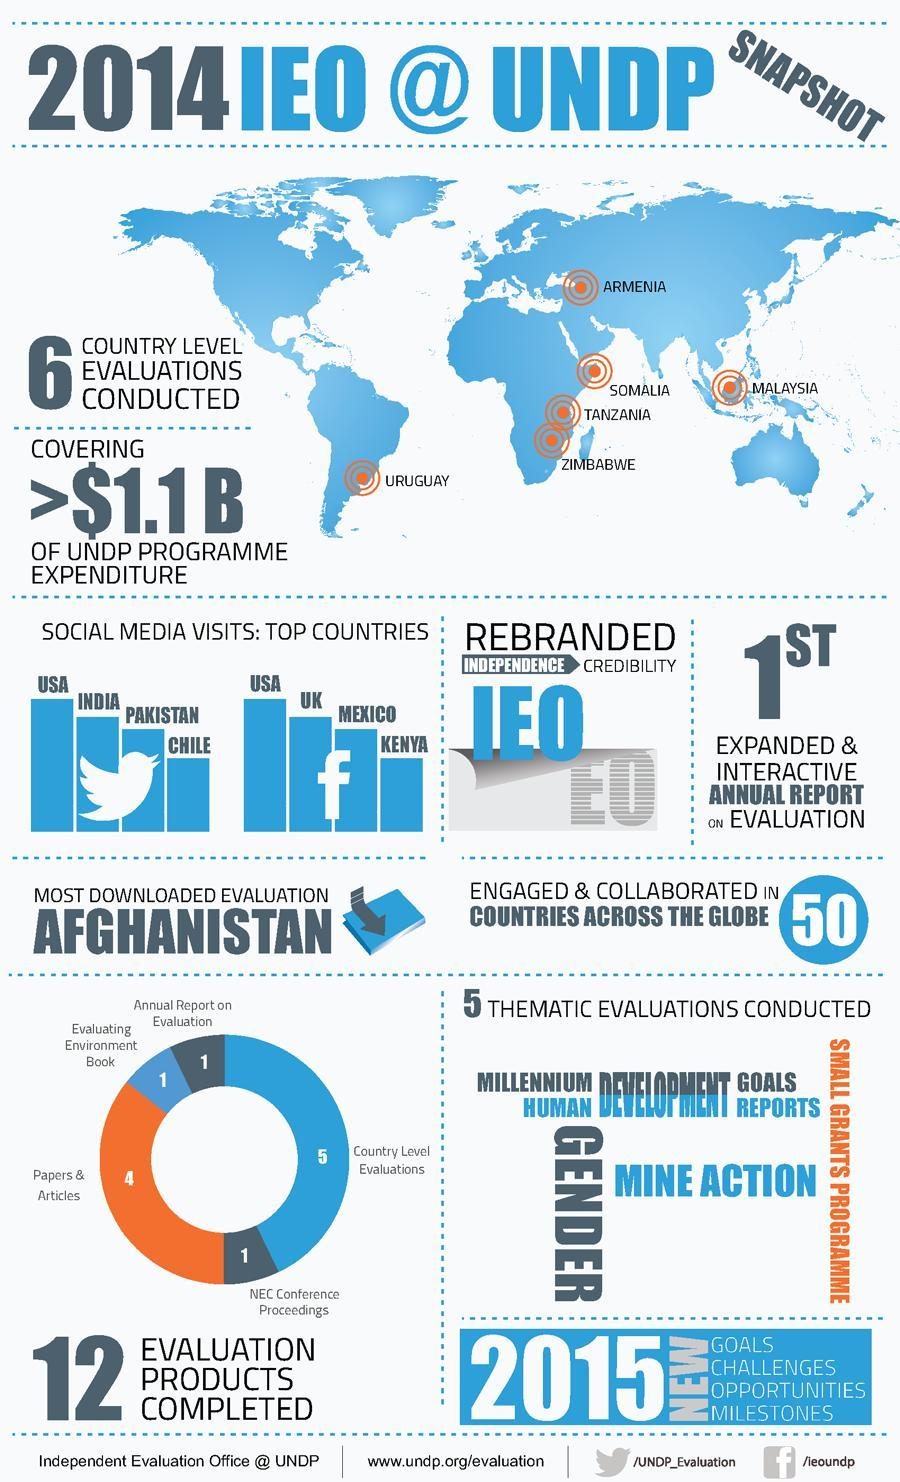Which country has the second highest number of facebook users in 2014?
Answer the question with a short phrase. UK Which country has the highest number of facebook users in 2014? USA Which country has the second highest number of twitter users in 2014? INDIA 